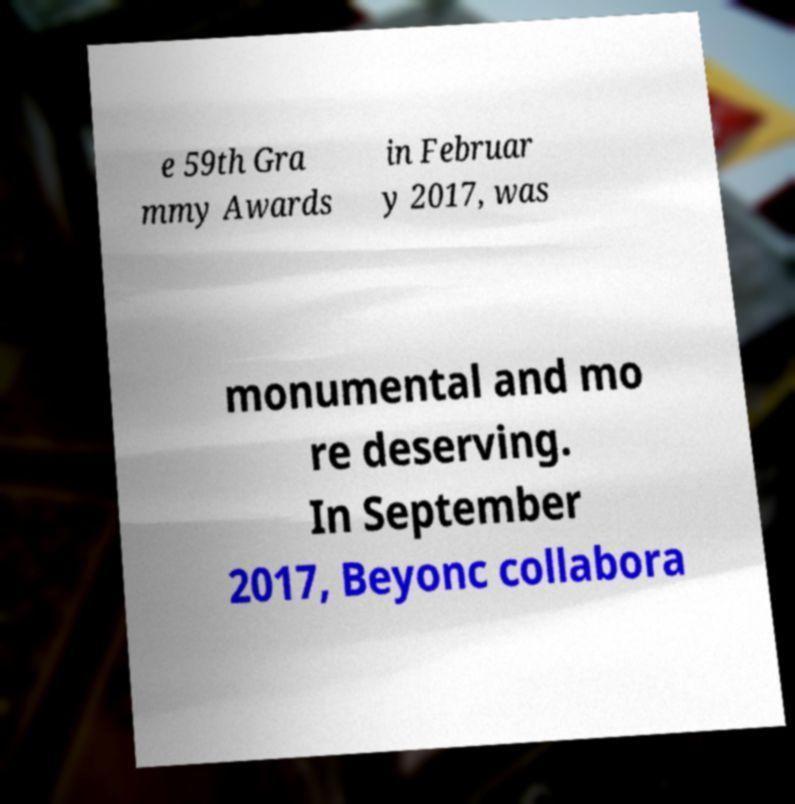Please identify and transcribe the text found in this image. e 59th Gra mmy Awards in Februar y 2017, was monumental and mo re deserving. In September 2017, Beyonc collabora 